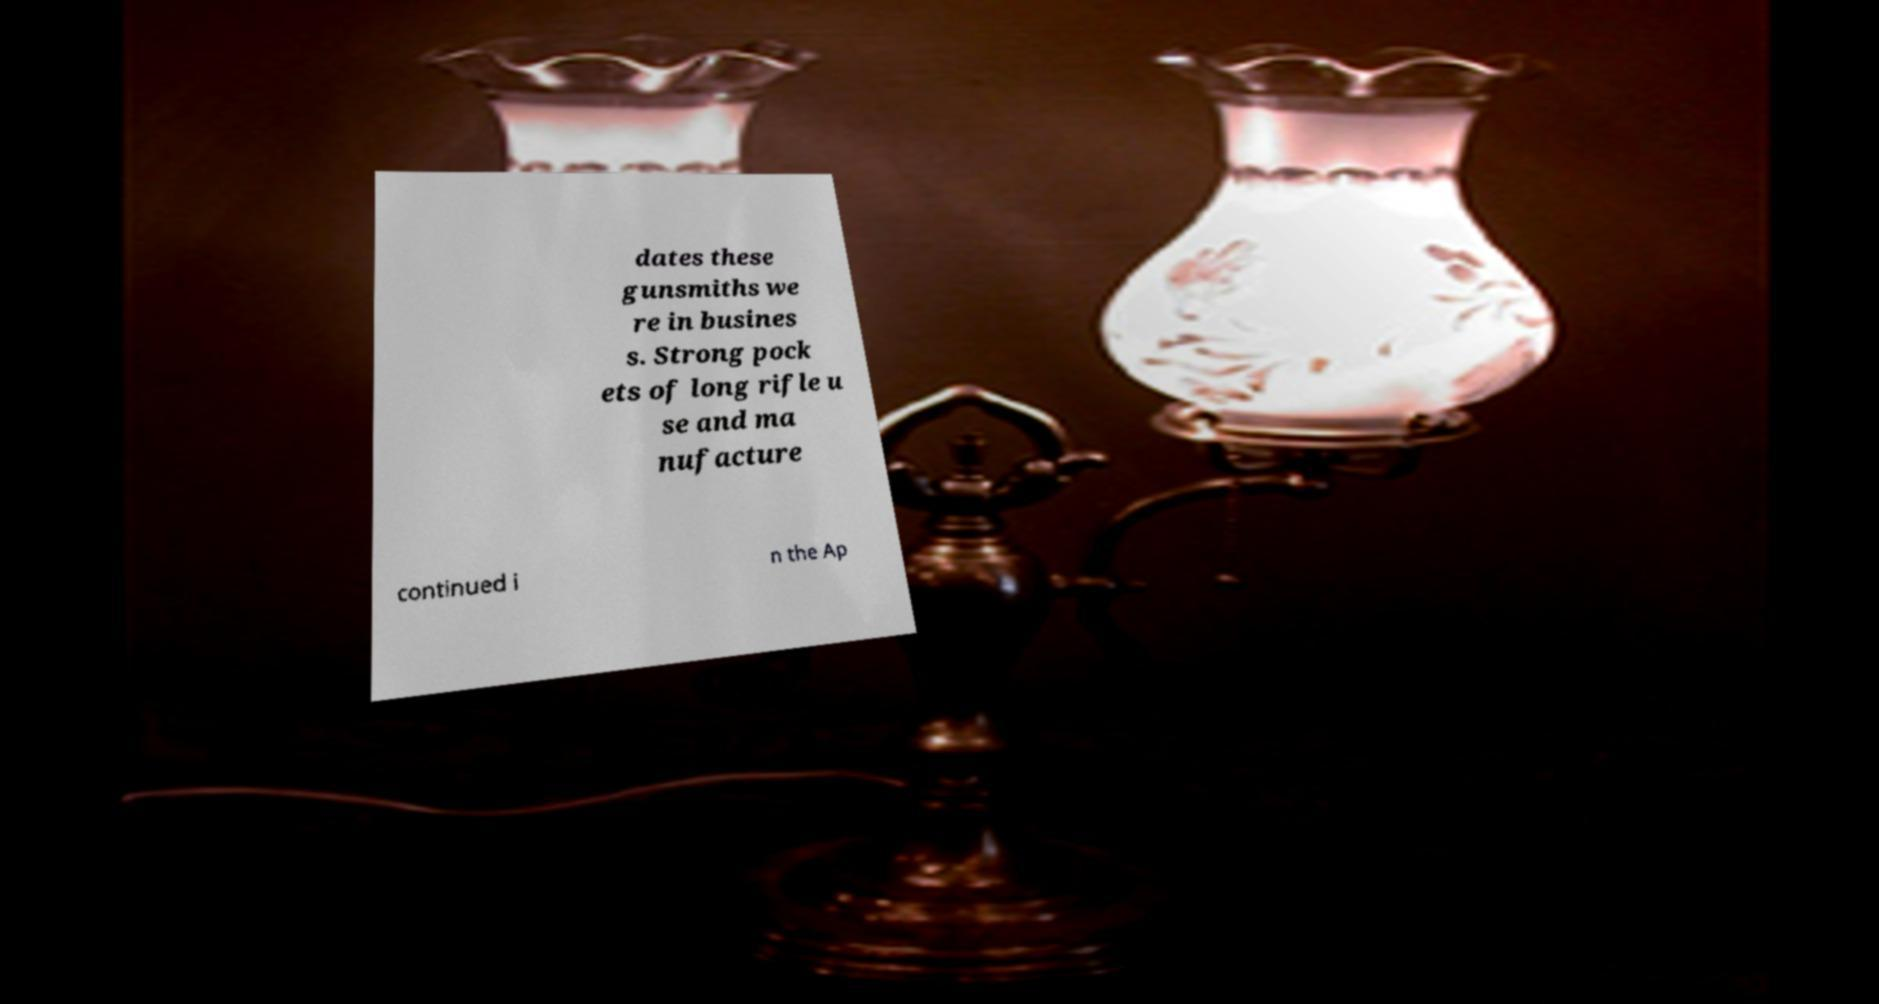What messages or text are displayed in this image? I need them in a readable, typed format. dates these gunsmiths we re in busines s. Strong pock ets of long rifle u se and ma nufacture continued i n the Ap 